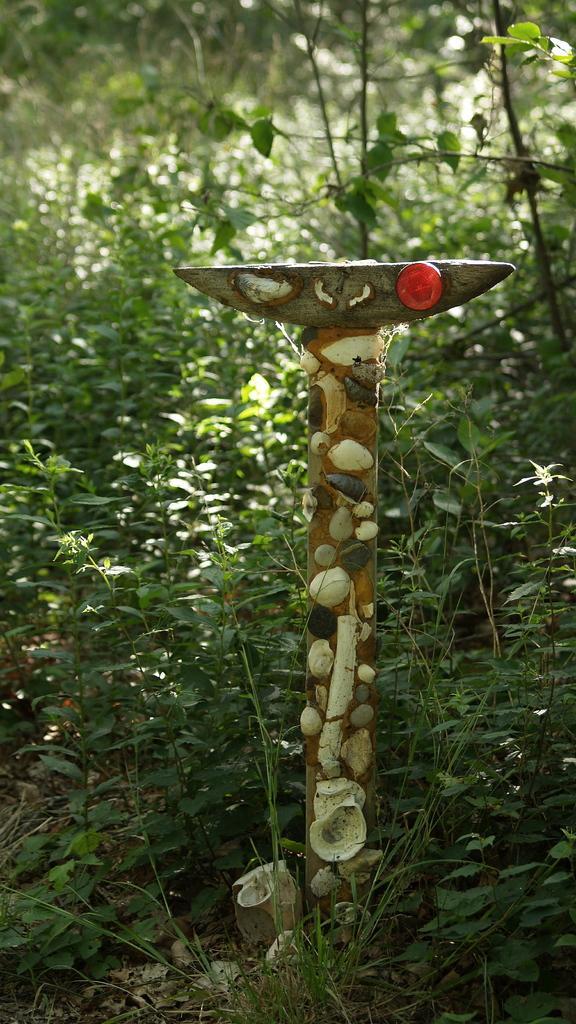Please provide a concise description of this image. Here we can see seals on an object. In the background there are plants. 